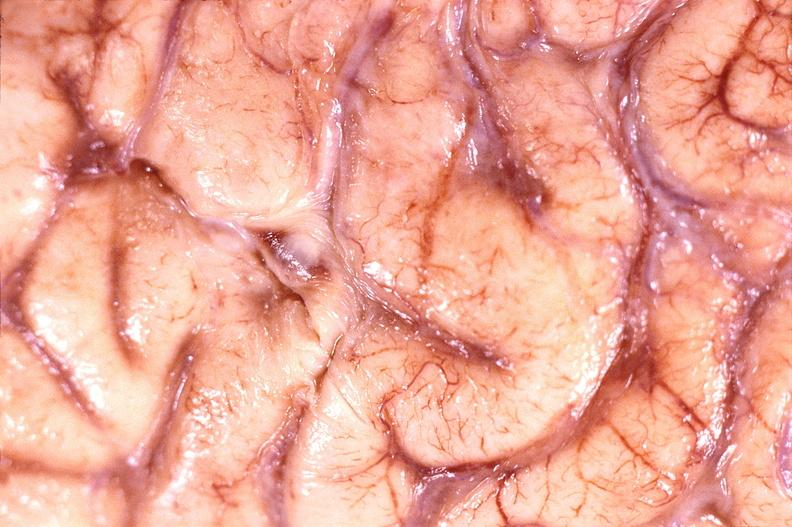s polysplenia present?
Answer the question using a single word or phrase. No 